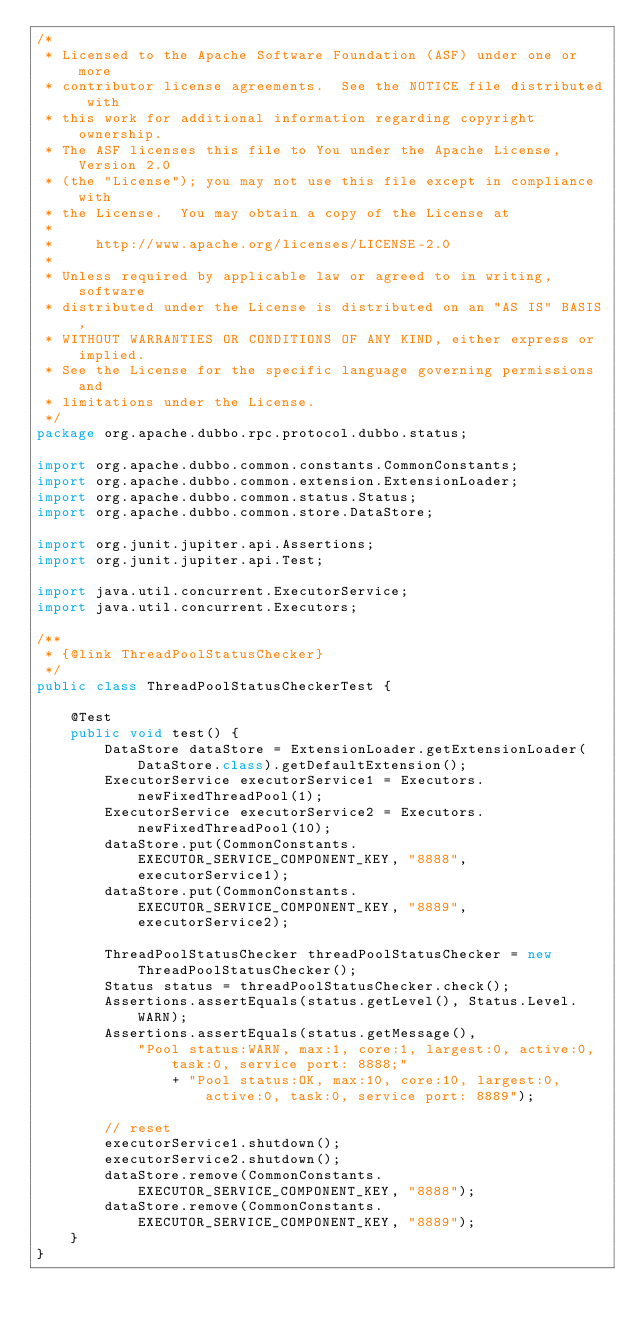<code> <loc_0><loc_0><loc_500><loc_500><_Java_>/*
 * Licensed to the Apache Software Foundation (ASF) under one or more
 * contributor license agreements.  See the NOTICE file distributed with
 * this work for additional information regarding copyright ownership.
 * The ASF licenses this file to You under the Apache License, Version 2.0
 * (the "License"); you may not use this file except in compliance with
 * the License.  You may obtain a copy of the License at
 *
 *     http://www.apache.org/licenses/LICENSE-2.0
 *
 * Unless required by applicable law or agreed to in writing, software
 * distributed under the License is distributed on an "AS IS" BASIS,
 * WITHOUT WARRANTIES OR CONDITIONS OF ANY KIND, either express or implied.
 * See the License for the specific language governing permissions and
 * limitations under the License.
 */
package org.apache.dubbo.rpc.protocol.dubbo.status;

import org.apache.dubbo.common.constants.CommonConstants;
import org.apache.dubbo.common.extension.ExtensionLoader;
import org.apache.dubbo.common.status.Status;
import org.apache.dubbo.common.store.DataStore;

import org.junit.jupiter.api.Assertions;
import org.junit.jupiter.api.Test;

import java.util.concurrent.ExecutorService;
import java.util.concurrent.Executors;

/**
 * {@link ThreadPoolStatusChecker}
 */
public class ThreadPoolStatusCheckerTest {

    @Test
    public void test() {
        DataStore dataStore = ExtensionLoader.getExtensionLoader(DataStore.class).getDefaultExtension();
        ExecutorService executorService1 = Executors.newFixedThreadPool(1);
        ExecutorService executorService2 = Executors.newFixedThreadPool(10);
        dataStore.put(CommonConstants.EXECUTOR_SERVICE_COMPONENT_KEY, "8888", executorService1);
        dataStore.put(CommonConstants.EXECUTOR_SERVICE_COMPONENT_KEY, "8889", executorService2);

        ThreadPoolStatusChecker threadPoolStatusChecker = new ThreadPoolStatusChecker();
        Status status = threadPoolStatusChecker.check();
        Assertions.assertEquals(status.getLevel(), Status.Level.WARN);
        Assertions.assertEquals(status.getMessage(),
            "Pool status:WARN, max:1, core:1, largest:0, active:0, task:0, service port: 8888;"
                + "Pool status:OK, max:10, core:10, largest:0, active:0, task:0, service port: 8889");

        // reset
        executorService1.shutdown();
        executorService2.shutdown();
        dataStore.remove(CommonConstants.EXECUTOR_SERVICE_COMPONENT_KEY, "8888");
        dataStore.remove(CommonConstants.EXECUTOR_SERVICE_COMPONENT_KEY, "8889");
    }
}
</code> 